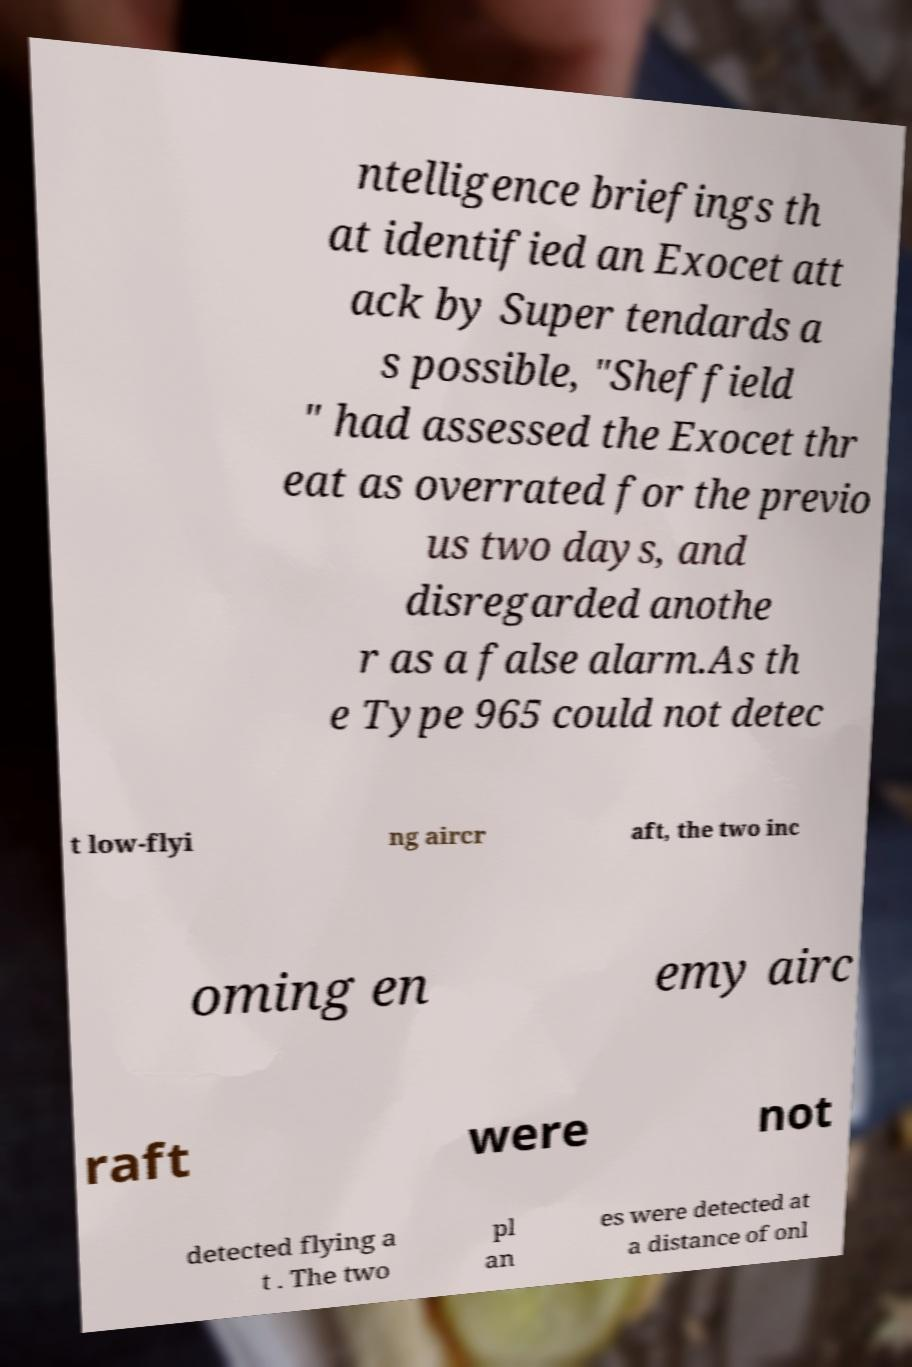Could you extract and type out the text from this image? ntelligence briefings th at identified an Exocet att ack by Super tendards a s possible, "Sheffield " had assessed the Exocet thr eat as overrated for the previo us two days, and disregarded anothe r as a false alarm.As th e Type 965 could not detec t low-flyi ng aircr aft, the two inc oming en emy airc raft were not detected flying a t . The two pl an es were detected at a distance of onl 